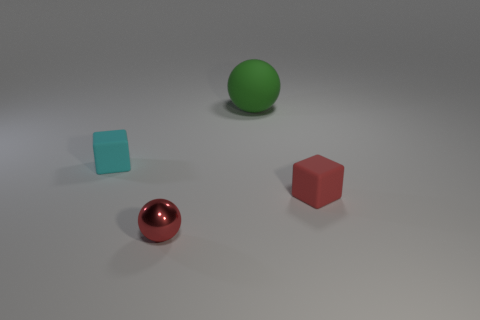How many other objects are there of the same size as the cyan rubber object?
Keep it short and to the point. 2. Is the color of the metal sphere the same as the big rubber object?
Offer a terse response. No. There is another object that is the same shape as the red rubber thing; what is it made of?
Give a very brief answer. Rubber. Are there any other things that are the same material as the large green ball?
Your answer should be compact. Yes. Is the number of red balls right of the tiny red sphere the same as the number of tiny red cubes that are behind the green matte ball?
Your answer should be very brief. Yes. Is the small red cube made of the same material as the big sphere?
Offer a very short reply. Yes. How many green things are big matte spheres or rubber things?
Your answer should be very brief. 1. How many red objects are the same shape as the green object?
Provide a short and direct response. 1. What is the cyan cube made of?
Provide a succinct answer. Rubber. Are there the same number of small matte things that are behind the large rubber object and big green shiny spheres?
Ensure brevity in your answer.  Yes. 